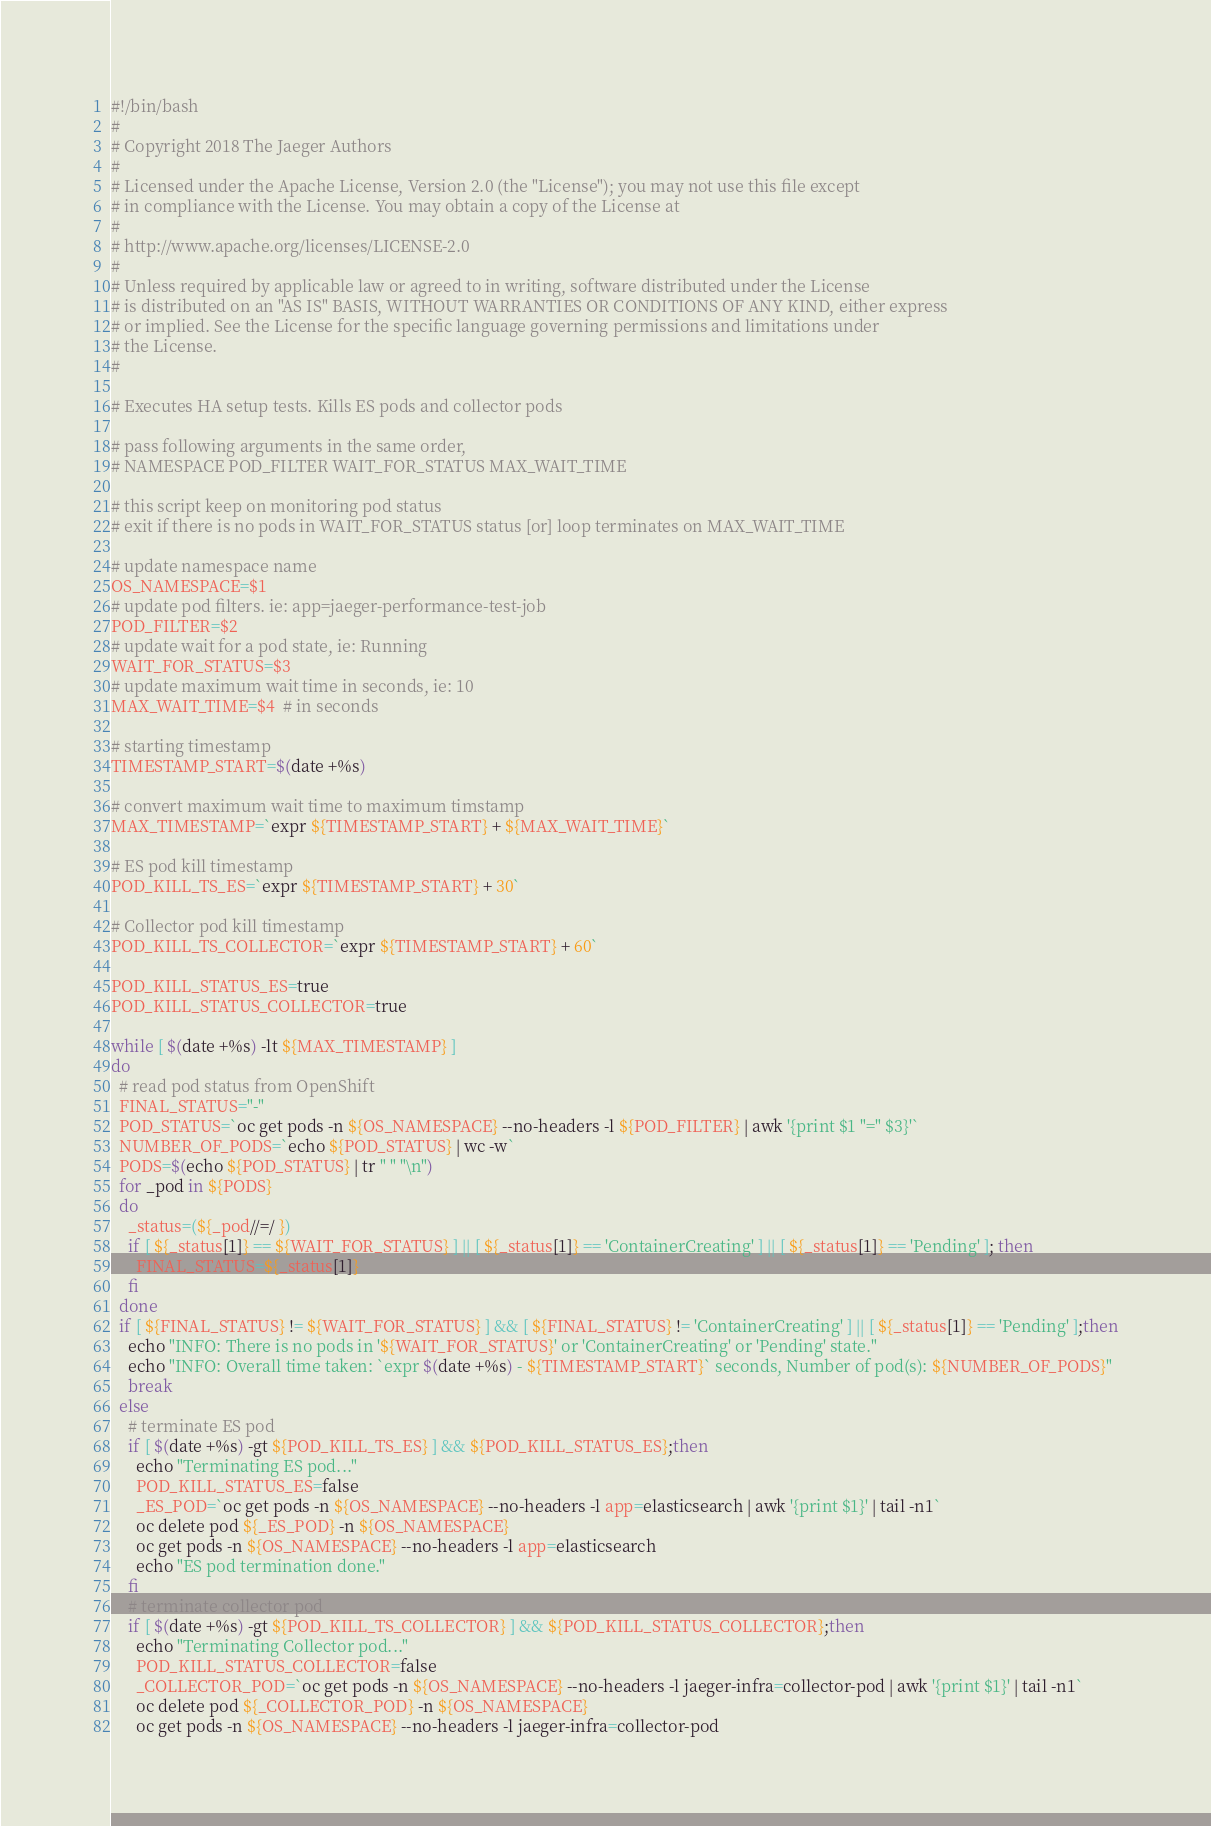<code> <loc_0><loc_0><loc_500><loc_500><_Bash_>#!/bin/bash
#
# Copyright 2018 The Jaeger Authors
#
# Licensed under the Apache License, Version 2.0 (the "License"); you may not use this file except
# in compliance with the License. You may obtain a copy of the License at
#
# http://www.apache.org/licenses/LICENSE-2.0
#
# Unless required by applicable law or agreed to in writing, software distributed under the License
# is distributed on an "AS IS" BASIS, WITHOUT WARRANTIES OR CONDITIONS OF ANY KIND, either express
# or implied. See the License for the specific language governing permissions and limitations under
# the License.
#

# Executes HA setup tests. Kills ES pods and collector pods

# pass following arguments in the same order,
# NAMESPACE POD_FILTER WAIT_FOR_STATUS MAX_WAIT_TIME

# this script keep on monitoring pod status
# exit if there is no pods in WAIT_FOR_STATUS status [or] loop terminates on MAX_WAIT_TIME

# update namespace name
OS_NAMESPACE=$1
# update pod filters. ie: app=jaeger-performance-test-job
POD_FILTER=$2
# update wait for a pod state, ie: Running
WAIT_FOR_STATUS=$3
# update maximum wait time in seconds, ie: 10
MAX_WAIT_TIME=$4  # in seconds

# starting timestamp
TIMESTAMP_START=$(date +%s)

# convert maximum wait time to maximum timstamp
MAX_TIMESTAMP=`expr ${TIMESTAMP_START} + ${MAX_WAIT_TIME}`

# ES pod kill timestamp
POD_KILL_TS_ES=`expr ${TIMESTAMP_START} + 30`

# Collector pod kill timestamp
POD_KILL_TS_COLLECTOR=`expr ${TIMESTAMP_START} + 60`

POD_KILL_STATUS_ES=true
POD_KILL_STATUS_COLLECTOR=true

while [ $(date +%s) -lt ${MAX_TIMESTAMP} ]
do
  # read pod status from OpenShift
  FINAL_STATUS="-"
  POD_STATUS=`oc get pods -n ${OS_NAMESPACE} --no-headers -l ${POD_FILTER} | awk '{print $1 "=" $3}'`
  NUMBER_OF_PODS=`echo ${POD_STATUS} | wc -w`
  PODS=$(echo ${POD_STATUS} | tr " " "\n")
  for _pod in ${PODS}
  do
    _status=(${_pod//=/ })
    if [ ${_status[1]} == ${WAIT_FOR_STATUS} ] || [ ${_status[1]} == 'ContainerCreating' ] || [ ${_status[1]} == 'Pending' ]; then
      FINAL_STATUS=${_status[1]}
    fi
  done
  if [ ${FINAL_STATUS} != ${WAIT_FOR_STATUS} ] && [ ${FINAL_STATUS} != 'ContainerCreating' ] || [ ${_status[1]} == 'Pending' ];then
    echo "INFO: There is no pods in '${WAIT_FOR_STATUS}' or 'ContainerCreating' or 'Pending' state."
    echo "INFO: Overall time taken: `expr $(date +%s) - ${TIMESTAMP_START}` seconds, Number of pod(s): ${NUMBER_OF_PODS}" 
    break
  else
    # terminate ES pod
    if [ $(date +%s) -gt ${POD_KILL_TS_ES} ] && ${POD_KILL_STATUS_ES};then
      echo "Terminating ES pod..."
      POD_KILL_STATUS_ES=false
      _ES_POD=`oc get pods -n ${OS_NAMESPACE} --no-headers -l app=elasticsearch | awk '{print $1}' | tail -n1`
      oc delete pod ${_ES_POD} -n ${OS_NAMESPACE}
      oc get pods -n ${OS_NAMESPACE} --no-headers -l app=elasticsearch
      echo "ES pod termination done."
    fi
    # terminate collector pod
    if [ $(date +%s) -gt ${POD_KILL_TS_COLLECTOR} ] && ${POD_KILL_STATUS_COLLECTOR};then
      echo "Terminating Collector pod..."
      POD_KILL_STATUS_COLLECTOR=false
      _COLLECTOR_POD=`oc get pods -n ${OS_NAMESPACE} --no-headers -l jaeger-infra=collector-pod | awk '{print $1}' | tail -n1`
      oc delete pod ${_COLLECTOR_POD} -n ${OS_NAMESPACE}
      oc get pods -n ${OS_NAMESPACE} --no-headers -l jaeger-infra=collector-pod</code> 